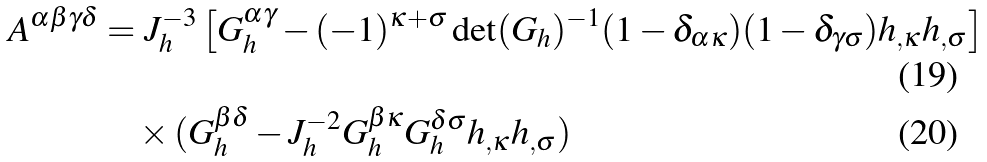Convert formula to latex. <formula><loc_0><loc_0><loc_500><loc_500>A ^ { \alpha \beta \gamma \delta } = & \ J _ { h } ^ { - 3 } \left [ G _ { h } ^ { \alpha \gamma } - ( - 1 ) ^ { \kappa + \sigma } \det ( G _ { h } ) ^ { - 1 } ( 1 - \delta _ { \alpha \kappa } ) ( 1 - \delta _ { \gamma \sigma } ) h _ { , \kappa } h _ { , \sigma } \right ] \\ & \times ( G _ { h } ^ { \beta \delta } - J _ { h } ^ { - 2 } G _ { h } ^ { \beta \kappa } G _ { h } ^ { \delta \sigma } h _ { , \kappa } h _ { , \sigma } )</formula> 